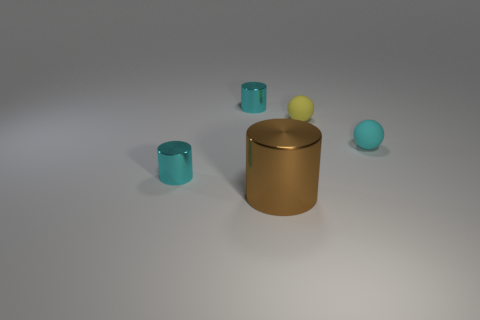Is there anything else that is the same size as the brown metallic object?
Your answer should be compact. No. There is a small metallic object behind the tiny cyan sphere; what is its color?
Keep it short and to the point. Cyan. There is a cyan object right of the large thing to the right of the tiny cyan cylinder that is in front of the cyan sphere; what is it made of?
Make the answer very short. Rubber. There is a cyan cylinder that is in front of the small metal thing that is behind the tiny cyan matte ball; how big is it?
Make the answer very short. Small. The other thing that is the same shape as the small cyan rubber object is what color?
Offer a very short reply. Yellow. What number of balls are the same color as the large metal cylinder?
Provide a succinct answer. 0. Do the cyan rubber ball and the brown metallic cylinder have the same size?
Provide a short and direct response. No. What is the yellow ball made of?
Provide a short and direct response. Rubber. What color is the thing that is made of the same material as the yellow ball?
Make the answer very short. Cyan. Does the large object have the same material as the cyan object to the right of the large brown shiny object?
Your answer should be compact. No. 